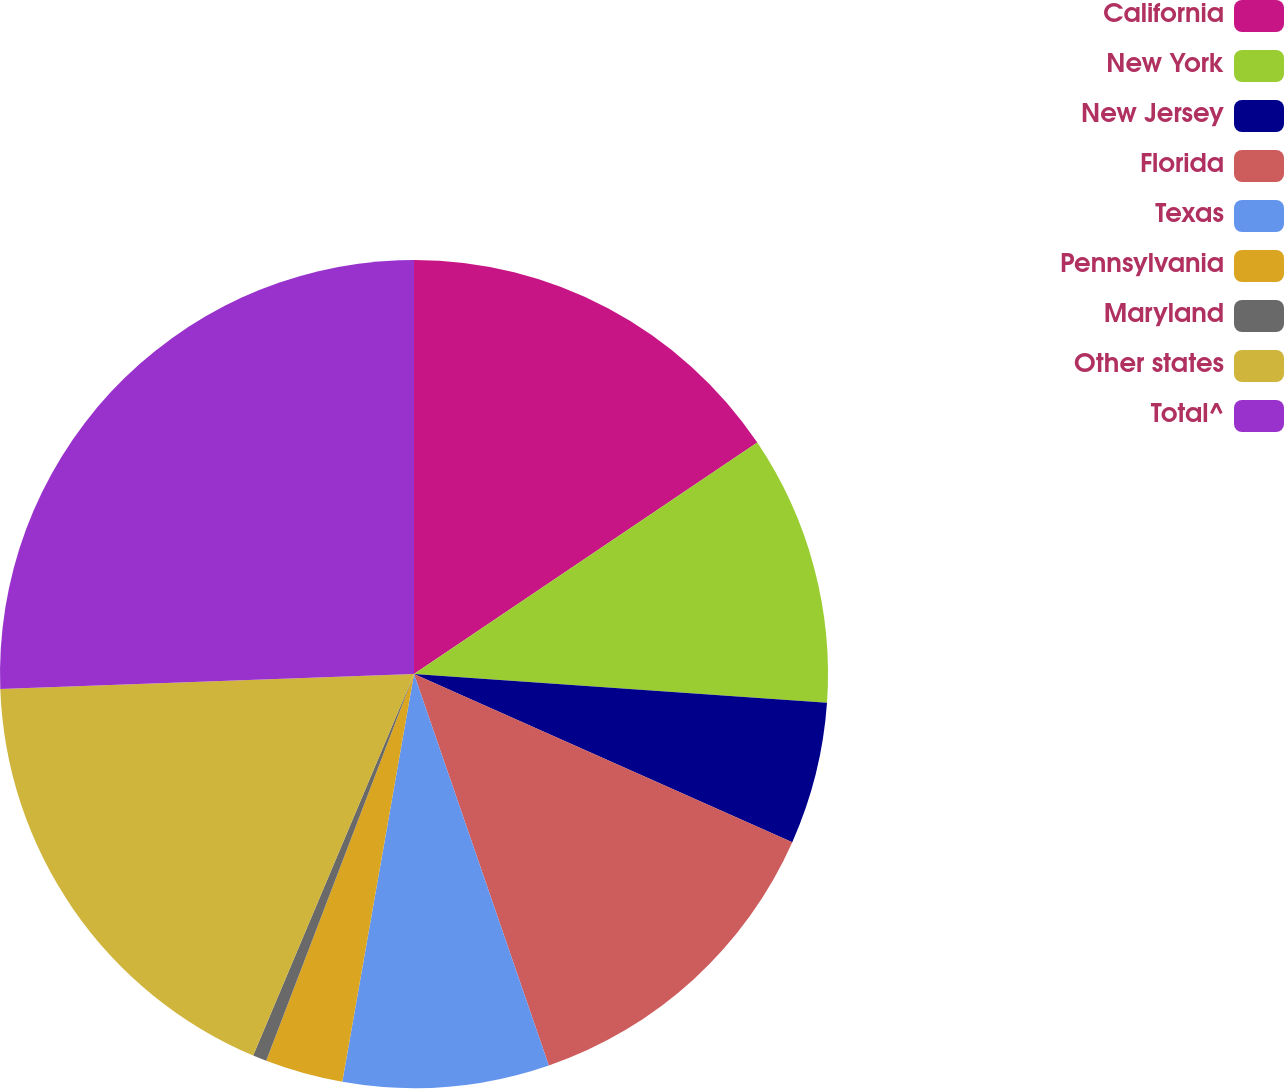Convert chart to OTSL. <chart><loc_0><loc_0><loc_500><loc_500><pie_chart><fcel>California<fcel>New York<fcel>New Jersey<fcel>Florida<fcel>Texas<fcel>Pennsylvania<fcel>Maryland<fcel>Other states<fcel>Total^<nl><fcel>15.56%<fcel>10.55%<fcel>5.55%<fcel>13.06%<fcel>8.05%<fcel>3.04%<fcel>0.54%<fcel>18.07%<fcel>25.58%<nl></chart> 